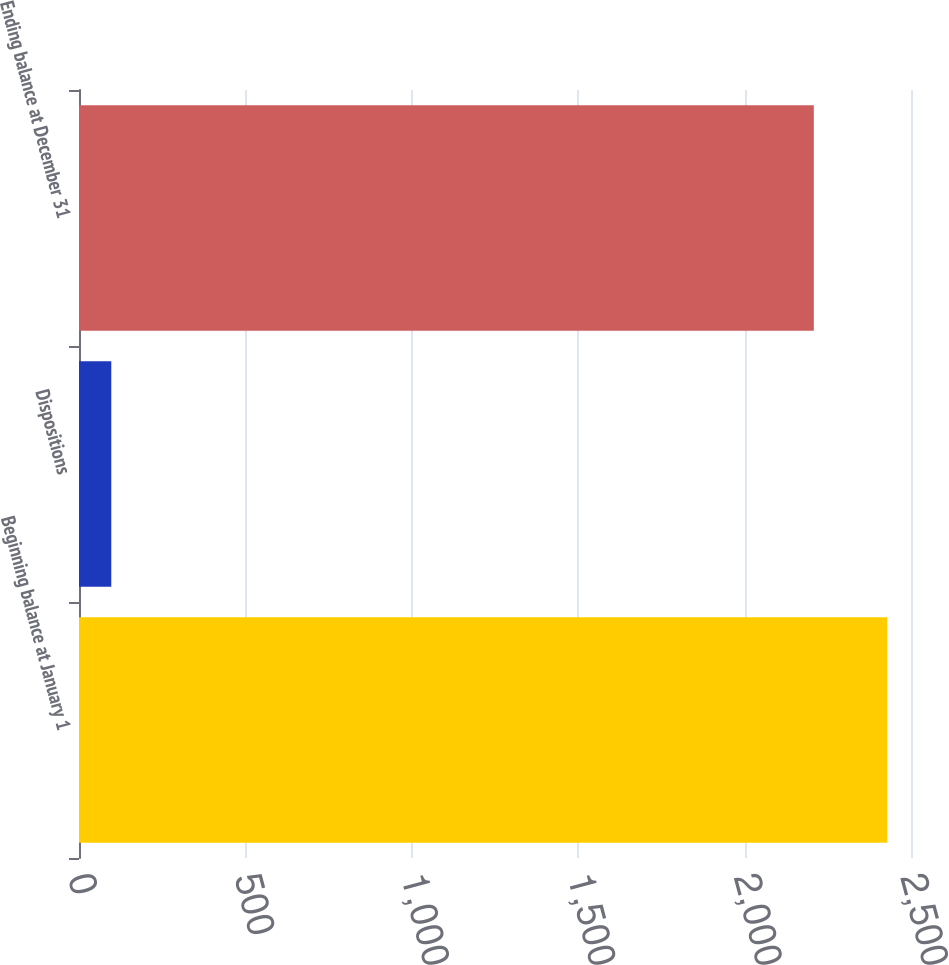Convert chart. <chart><loc_0><loc_0><loc_500><loc_500><bar_chart><fcel>Beginning balance at January 1<fcel>Dispositions<fcel>Ending balance at December 31<nl><fcel>2428.8<fcel>97<fcel>2208<nl></chart> 